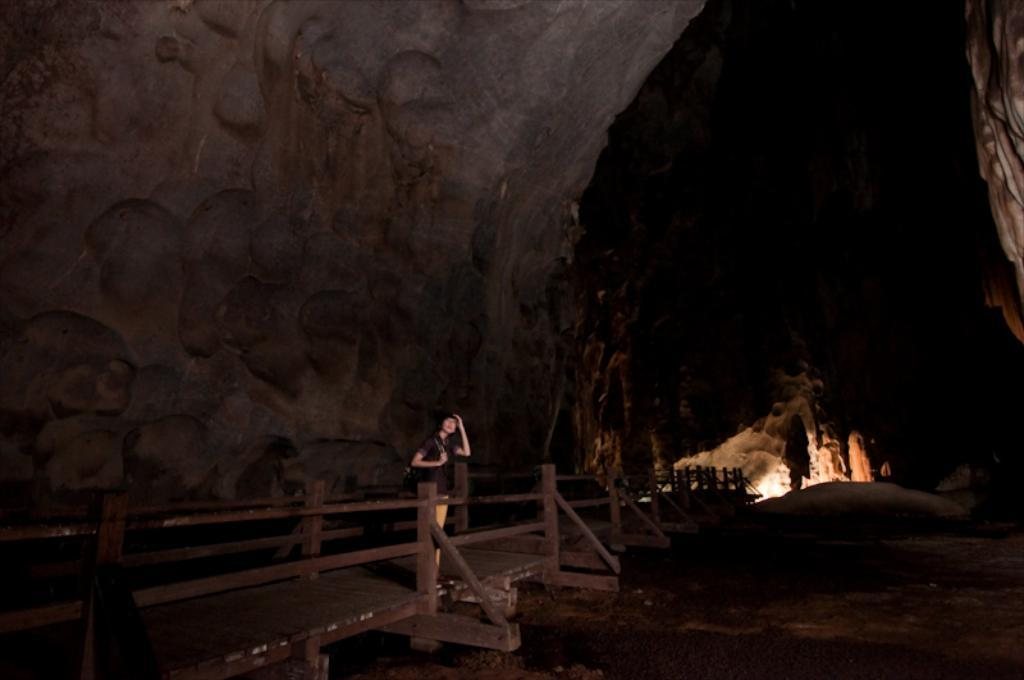What is the main subject of the image? There is a person standing in the image. What can be seen in the background of the image? There is a fence, lights, and other objects on the ground in the background of the image. How would you describe the lighting in the image? The image is described as being a little bit dark. What type of trees can be seen in the image? There are no trees visible in the image. How much paste is being used by the person in the image? There is no paste present in the image, and the person is not using any. 